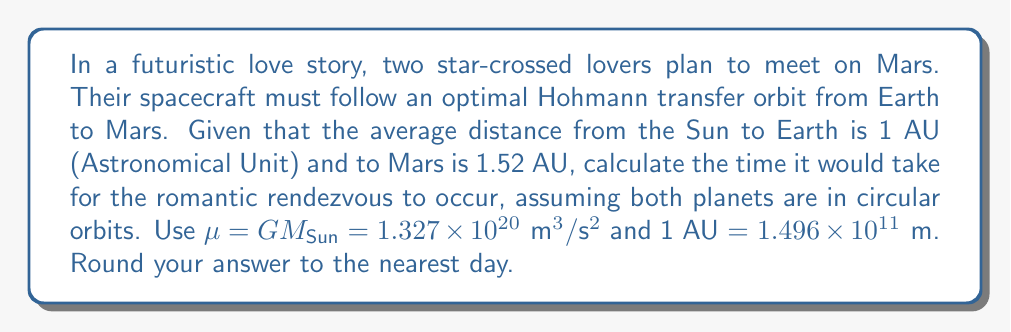Solve this math problem. To solve this romantic interplanetary problem, we'll use the principles of orbital mechanics and the Hohmann transfer orbit.

1) First, we need to calculate the semi-major axis of the transfer orbit:
   $$a = \frac{r_1 + r_2}{2} = \frac{1 \text{ AU} + 1.52 \text{ AU}}{2} = 1.26 \text{ AU}$$

2) Convert this to meters:
   $$a = 1.26 \times 1.496 \times 10^{11} \text{ m} = 1.885 \times 10^{11} \text{ m}$$

3) The time for half an orbit (Earth to Mars) is given by:
   $$T = \pi \sqrt{\frac{a^3}{\mu}}$$

4) Substituting the values:
   $$T = \pi \sqrt{\frac{(1.885 \times 10^{11})^3}{1.327 \times 10^{20}}}$$

5) Calculating:
   $$T = 1.364 \times 10^7 \text{ seconds}$$

6) Convert to days:
   $$T = \frac{1.364 \times 10^7}{86400} = 157.9 \text{ days}$$

7) Rounding to the nearest day:
   $$T \approx 158 \text{ days}$$
Answer: 158 days 